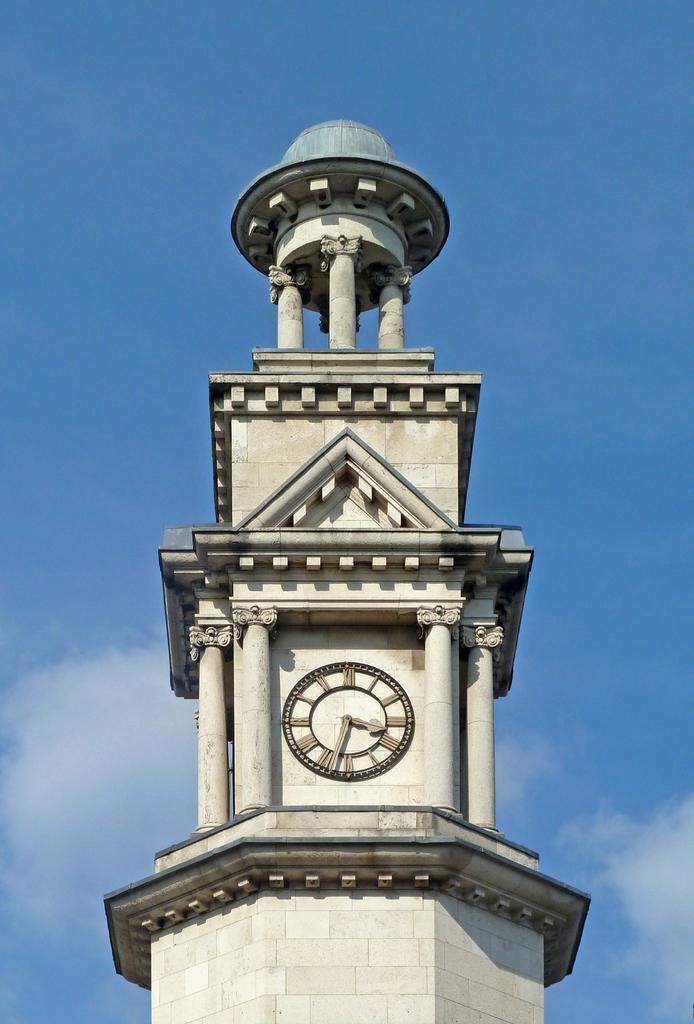<image>
Relay a brief, clear account of the picture shown. a clock that has roman numerals on the front of it 